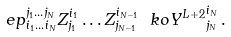Convert formula to latex. <formula><loc_0><loc_0><loc_500><loc_500>\ e p ^ { j _ { 1 } \dots j _ { N } } _ { i _ { 1 } \dots i _ { N } } Z ^ { i _ { 1 } } _ { j _ { 1 } } \dots Z ^ { i _ { N - 1 } } _ { j _ { N - 1 } } \ k o { Y ^ { L + 2 } } ^ { i _ { N } } _ { j _ { N } } \, .</formula> 